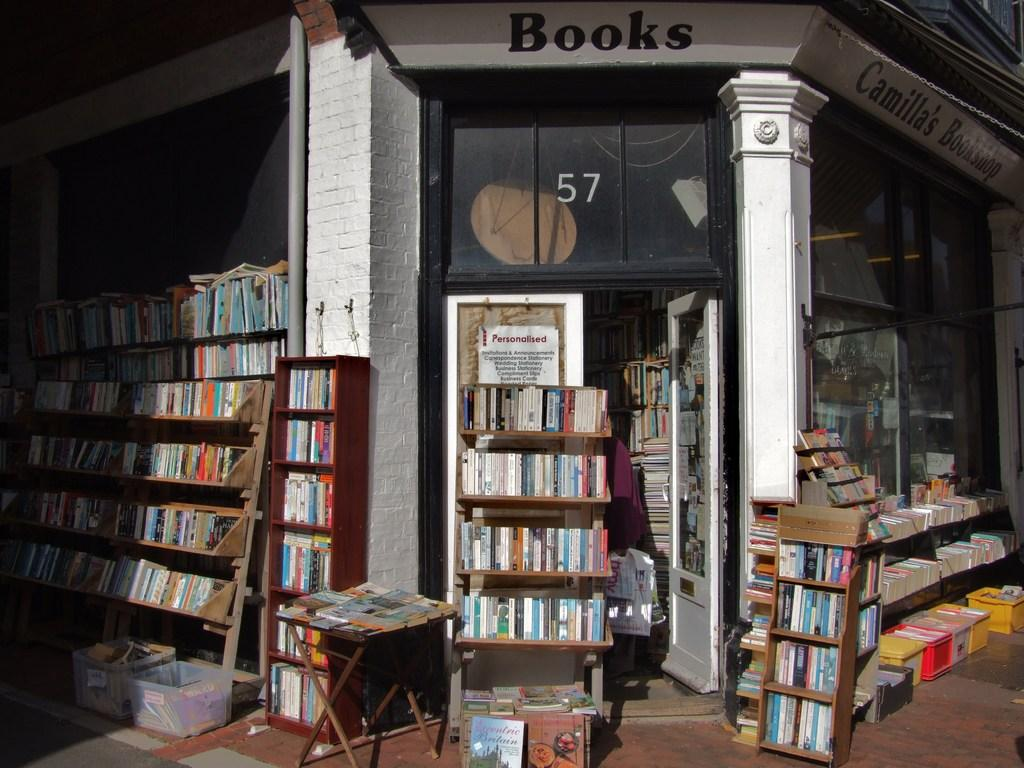What type of establishment is shown in the image? The image depicts a book store. How are the books arranged in the book store? The books are on bookshelves, on a table, and in boxes in the image. Can you describe the books on the table in the image? The image shows books on a table, but it does not provide specific details about the books. What type of advertisement can be seen on the wall in the image? There is no advertisement visible on the wall in the image; it only shows books on bookshelves, on a table, and in boxes. How many dogs are present in the image? There are no dogs present in the image; it only shows books in a book store. 